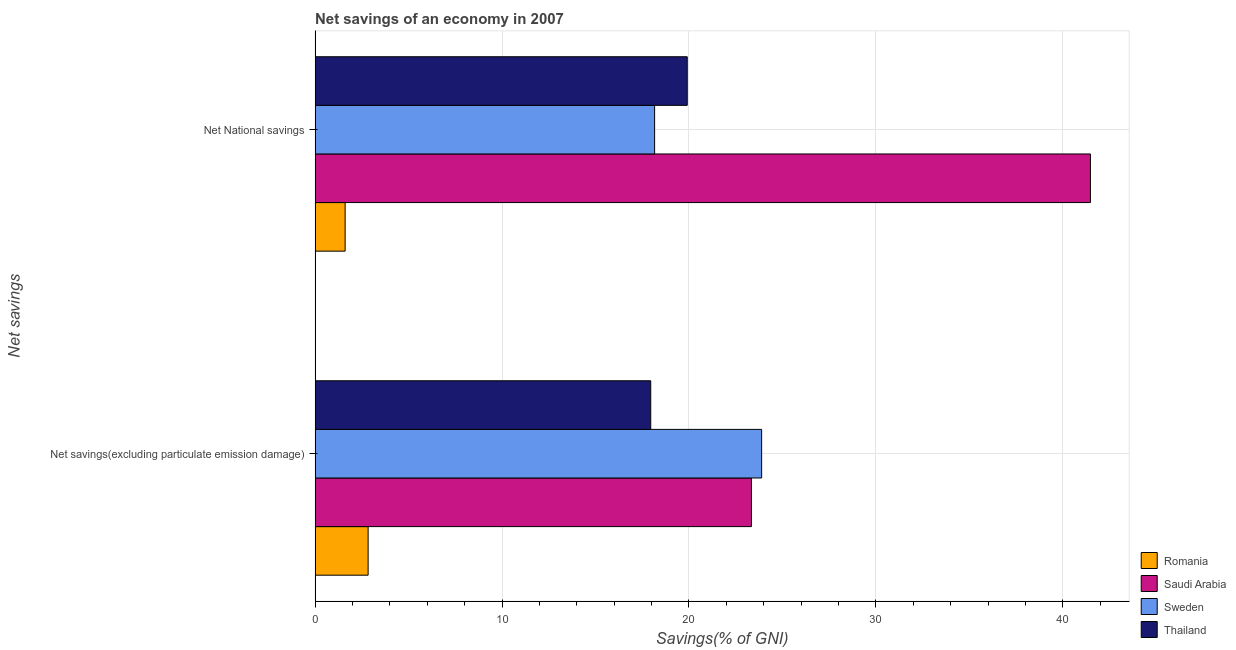How many groups of bars are there?
Your answer should be compact. 2. Are the number of bars per tick equal to the number of legend labels?
Ensure brevity in your answer.  Yes. How many bars are there on the 2nd tick from the top?
Your response must be concise. 4. What is the label of the 1st group of bars from the top?
Your answer should be very brief. Net National savings. What is the net national savings in Thailand?
Give a very brief answer. 19.91. Across all countries, what is the maximum net national savings?
Ensure brevity in your answer.  41.48. Across all countries, what is the minimum net national savings?
Give a very brief answer. 1.61. In which country was the net national savings maximum?
Ensure brevity in your answer.  Saudi Arabia. In which country was the net savings(excluding particulate emission damage) minimum?
Provide a short and direct response. Romania. What is the total net national savings in the graph?
Ensure brevity in your answer.  81.15. What is the difference between the net savings(excluding particulate emission damage) in Saudi Arabia and that in Romania?
Provide a succinct answer. 20.51. What is the difference between the net national savings in Saudi Arabia and the net savings(excluding particulate emission damage) in Sweden?
Offer a terse response. 17.59. What is the average net national savings per country?
Keep it short and to the point. 20.29. What is the difference between the net national savings and net savings(excluding particulate emission damage) in Romania?
Your response must be concise. -1.23. What is the ratio of the net national savings in Saudi Arabia to that in Thailand?
Provide a succinct answer. 2.08. Is the net savings(excluding particulate emission damage) in Sweden less than that in Saudi Arabia?
Keep it short and to the point. No. In how many countries, is the net national savings greater than the average net national savings taken over all countries?
Give a very brief answer. 1. What does the 1st bar from the top in Net savings(excluding particulate emission damage) represents?
Your response must be concise. Thailand. What does the 1st bar from the bottom in Net National savings represents?
Provide a succinct answer. Romania. How many bars are there?
Provide a succinct answer. 8. Are all the bars in the graph horizontal?
Keep it short and to the point. Yes. What is the difference between two consecutive major ticks on the X-axis?
Give a very brief answer. 10. Does the graph contain any zero values?
Give a very brief answer. No. Does the graph contain grids?
Make the answer very short. Yes. Where does the legend appear in the graph?
Make the answer very short. Bottom right. What is the title of the graph?
Give a very brief answer. Net savings of an economy in 2007. Does "Cuba" appear as one of the legend labels in the graph?
Your answer should be very brief. No. What is the label or title of the X-axis?
Make the answer very short. Savings(% of GNI). What is the label or title of the Y-axis?
Your response must be concise. Net savings. What is the Savings(% of GNI) of Romania in Net savings(excluding particulate emission damage)?
Give a very brief answer. 2.84. What is the Savings(% of GNI) in Saudi Arabia in Net savings(excluding particulate emission damage)?
Make the answer very short. 23.34. What is the Savings(% of GNI) in Sweden in Net savings(excluding particulate emission damage)?
Your answer should be very brief. 23.89. What is the Savings(% of GNI) of Thailand in Net savings(excluding particulate emission damage)?
Your answer should be compact. 17.95. What is the Savings(% of GNI) in Romania in Net National savings?
Ensure brevity in your answer.  1.61. What is the Savings(% of GNI) of Saudi Arabia in Net National savings?
Provide a succinct answer. 41.48. What is the Savings(% of GNI) of Sweden in Net National savings?
Offer a very short reply. 18.16. What is the Savings(% of GNI) in Thailand in Net National savings?
Your response must be concise. 19.91. Across all Net savings, what is the maximum Savings(% of GNI) of Romania?
Ensure brevity in your answer.  2.84. Across all Net savings, what is the maximum Savings(% of GNI) of Saudi Arabia?
Your answer should be compact. 41.48. Across all Net savings, what is the maximum Savings(% of GNI) in Sweden?
Offer a terse response. 23.89. Across all Net savings, what is the maximum Savings(% of GNI) in Thailand?
Offer a terse response. 19.91. Across all Net savings, what is the minimum Savings(% of GNI) in Romania?
Offer a very short reply. 1.61. Across all Net savings, what is the minimum Savings(% of GNI) of Saudi Arabia?
Provide a short and direct response. 23.34. Across all Net savings, what is the minimum Savings(% of GNI) in Sweden?
Offer a very short reply. 18.16. Across all Net savings, what is the minimum Savings(% of GNI) of Thailand?
Your response must be concise. 17.95. What is the total Savings(% of GNI) in Romania in the graph?
Keep it short and to the point. 4.44. What is the total Savings(% of GNI) in Saudi Arabia in the graph?
Offer a very short reply. 64.82. What is the total Savings(% of GNI) of Sweden in the graph?
Offer a very short reply. 42.05. What is the total Savings(% of GNI) of Thailand in the graph?
Your response must be concise. 37.86. What is the difference between the Savings(% of GNI) in Romania in Net savings(excluding particulate emission damage) and that in Net National savings?
Give a very brief answer. 1.23. What is the difference between the Savings(% of GNI) in Saudi Arabia in Net savings(excluding particulate emission damage) and that in Net National savings?
Your response must be concise. -18.14. What is the difference between the Savings(% of GNI) in Sweden in Net savings(excluding particulate emission damage) and that in Net National savings?
Provide a succinct answer. 5.73. What is the difference between the Savings(% of GNI) in Thailand in Net savings(excluding particulate emission damage) and that in Net National savings?
Provide a short and direct response. -1.95. What is the difference between the Savings(% of GNI) in Romania in Net savings(excluding particulate emission damage) and the Savings(% of GNI) in Saudi Arabia in Net National savings?
Ensure brevity in your answer.  -38.64. What is the difference between the Savings(% of GNI) of Romania in Net savings(excluding particulate emission damage) and the Savings(% of GNI) of Sweden in Net National savings?
Provide a short and direct response. -15.33. What is the difference between the Savings(% of GNI) in Romania in Net savings(excluding particulate emission damage) and the Savings(% of GNI) in Thailand in Net National savings?
Provide a short and direct response. -17.07. What is the difference between the Savings(% of GNI) of Saudi Arabia in Net savings(excluding particulate emission damage) and the Savings(% of GNI) of Sweden in Net National savings?
Provide a succinct answer. 5.18. What is the difference between the Savings(% of GNI) in Saudi Arabia in Net savings(excluding particulate emission damage) and the Savings(% of GNI) in Thailand in Net National savings?
Provide a short and direct response. 3.43. What is the difference between the Savings(% of GNI) in Sweden in Net savings(excluding particulate emission damage) and the Savings(% of GNI) in Thailand in Net National savings?
Your answer should be very brief. 3.98. What is the average Savings(% of GNI) in Romania per Net savings?
Your response must be concise. 2.22. What is the average Savings(% of GNI) of Saudi Arabia per Net savings?
Give a very brief answer. 32.41. What is the average Savings(% of GNI) in Sweden per Net savings?
Offer a terse response. 21.02. What is the average Savings(% of GNI) in Thailand per Net savings?
Your answer should be very brief. 18.93. What is the difference between the Savings(% of GNI) in Romania and Savings(% of GNI) in Saudi Arabia in Net savings(excluding particulate emission damage)?
Provide a short and direct response. -20.51. What is the difference between the Savings(% of GNI) in Romania and Savings(% of GNI) in Sweden in Net savings(excluding particulate emission damage)?
Ensure brevity in your answer.  -21.05. What is the difference between the Savings(% of GNI) in Romania and Savings(% of GNI) in Thailand in Net savings(excluding particulate emission damage)?
Keep it short and to the point. -15.12. What is the difference between the Savings(% of GNI) in Saudi Arabia and Savings(% of GNI) in Sweden in Net savings(excluding particulate emission damage)?
Your answer should be compact. -0.55. What is the difference between the Savings(% of GNI) in Saudi Arabia and Savings(% of GNI) in Thailand in Net savings(excluding particulate emission damage)?
Make the answer very short. 5.39. What is the difference between the Savings(% of GNI) of Sweden and Savings(% of GNI) of Thailand in Net savings(excluding particulate emission damage)?
Keep it short and to the point. 5.93. What is the difference between the Savings(% of GNI) of Romania and Savings(% of GNI) of Saudi Arabia in Net National savings?
Provide a short and direct response. -39.87. What is the difference between the Savings(% of GNI) in Romania and Savings(% of GNI) in Sweden in Net National savings?
Offer a very short reply. -16.56. What is the difference between the Savings(% of GNI) of Romania and Savings(% of GNI) of Thailand in Net National savings?
Provide a succinct answer. -18.3. What is the difference between the Savings(% of GNI) of Saudi Arabia and Savings(% of GNI) of Sweden in Net National savings?
Your answer should be compact. 23.32. What is the difference between the Savings(% of GNI) of Saudi Arabia and Savings(% of GNI) of Thailand in Net National savings?
Your answer should be compact. 21.57. What is the difference between the Savings(% of GNI) in Sweden and Savings(% of GNI) in Thailand in Net National savings?
Give a very brief answer. -1.75. What is the ratio of the Savings(% of GNI) in Romania in Net savings(excluding particulate emission damage) to that in Net National savings?
Your response must be concise. 1.77. What is the ratio of the Savings(% of GNI) in Saudi Arabia in Net savings(excluding particulate emission damage) to that in Net National savings?
Your answer should be very brief. 0.56. What is the ratio of the Savings(% of GNI) in Sweden in Net savings(excluding particulate emission damage) to that in Net National savings?
Offer a very short reply. 1.32. What is the ratio of the Savings(% of GNI) of Thailand in Net savings(excluding particulate emission damage) to that in Net National savings?
Your answer should be compact. 0.9. What is the difference between the highest and the second highest Savings(% of GNI) in Romania?
Ensure brevity in your answer.  1.23. What is the difference between the highest and the second highest Savings(% of GNI) of Saudi Arabia?
Keep it short and to the point. 18.14. What is the difference between the highest and the second highest Savings(% of GNI) of Sweden?
Provide a short and direct response. 5.73. What is the difference between the highest and the second highest Savings(% of GNI) in Thailand?
Give a very brief answer. 1.95. What is the difference between the highest and the lowest Savings(% of GNI) in Romania?
Your response must be concise. 1.23. What is the difference between the highest and the lowest Savings(% of GNI) in Saudi Arabia?
Provide a succinct answer. 18.14. What is the difference between the highest and the lowest Savings(% of GNI) in Sweden?
Your answer should be very brief. 5.73. What is the difference between the highest and the lowest Savings(% of GNI) in Thailand?
Your answer should be very brief. 1.95. 